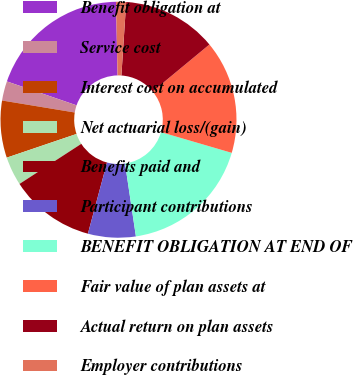Convert chart. <chart><loc_0><loc_0><loc_500><loc_500><pie_chart><fcel>Benefit obligation at<fcel>Service cost<fcel>Interest cost on accumulated<fcel>Net actuarial loss/(gain)<fcel>Benefits paid and<fcel>Participant contributions<fcel>BENEFIT OBLIGATION AT END OF<fcel>Fair value of plan assets at<fcel>Actual return on plan assets<fcel>Employer contributions<nl><fcel>19.4%<fcel>2.66%<fcel>7.81%<fcel>3.95%<fcel>11.67%<fcel>6.53%<fcel>18.11%<fcel>15.53%<fcel>12.96%<fcel>1.38%<nl></chart> 